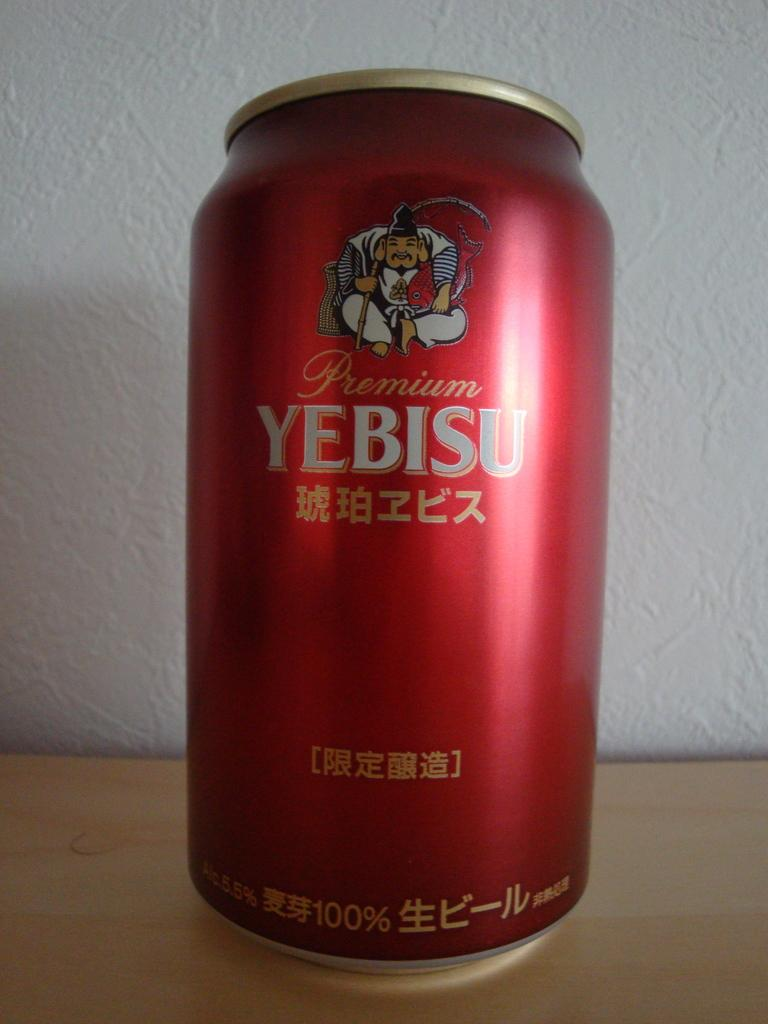<image>
Summarize the visual content of the image. A can of Premium Yebisu has a man with a fishing pole on the label. 